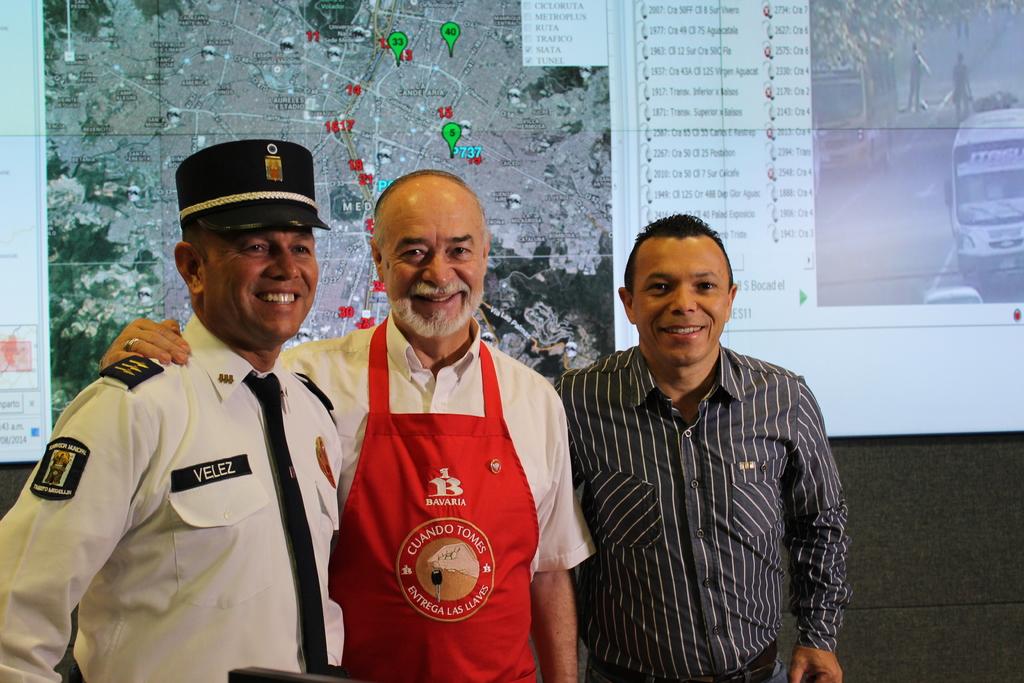What is the officer on the left's last name?
Provide a succinct answer. Velez. What store does the chef work for?
Offer a terse response. Bavaria. 